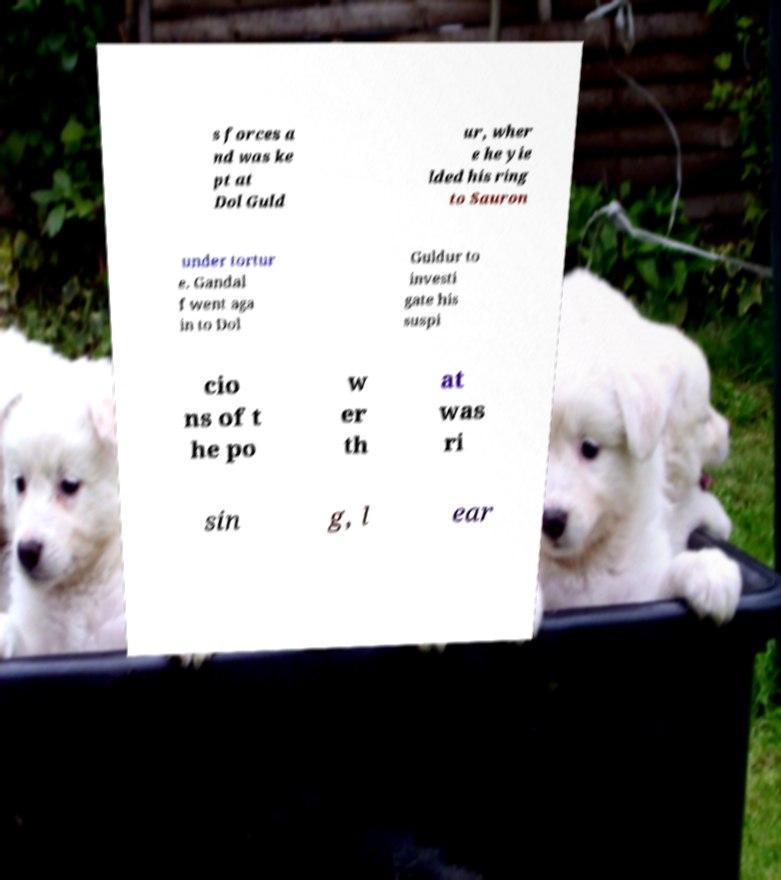Could you extract and type out the text from this image? s forces a nd was ke pt at Dol Guld ur, wher e he yie lded his ring to Sauron under tortur e. Gandal f went aga in to Dol Guldur to investi gate his suspi cio ns of t he po w er th at was ri sin g, l ear 